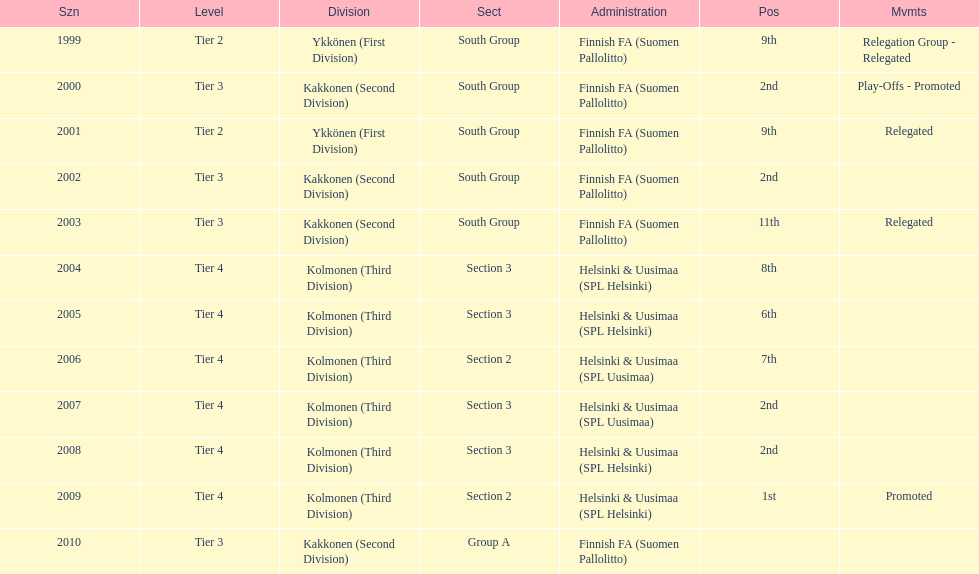How many times were they in tier 3? 4. Could you help me parse every detail presented in this table? {'header': ['Szn', 'Level', 'Division', 'Sect', 'Administration', 'Pos', 'Mvmts'], 'rows': [['1999', 'Tier 2', 'Ykkönen (First Division)', 'South Group', 'Finnish FA (Suomen Pallolitto)', '9th', 'Relegation Group - Relegated'], ['2000', 'Tier 3', 'Kakkonen (Second Division)', 'South Group', 'Finnish FA (Suomen Pallolitto)', '2nd', 'Play-Offs - Promoted'], ['2001', 'Tier 2', 'Ykkönen (First Division)', 'South Group', 'Finnish FA (Suomen Pallolitto)', '9th', 'Relegated'], ['2002', 'Tier 3', 'Kakkonen (Second Division)', 'South Group', 'Finnish FA (Suomen Pallolitto)', '2nd', ''], ['2003', 'Tier 3', 'Kakkonen (Second Division)', 'South Group', 'Finnish FA (Suomen Pallolitto)', '11th', 'Relegated'], ['2004', 'Tier 4', 'Kolmonen (Third Division)', 'Section 3', 'Helsinki & Uusimaa (SPL Helsinki)', '8th', ''], ['2005', 'Tier 4', 'Kolmonen (Third Division)', 'Section 3', 'Helsinki & Uusimaa (SPL Helsinki)', '6th', ''], ['2006', 'Tier 4', 'Kolmonen (Third Division)', 'Section 2', 'Helsinki & Uusimaa (SPL Uusimaa)', '7th', ''], ['2007', 'Tier 4', 'Kolmonen (Third Division)', 'Section 3', 'Helsinki & Uusimaa (SPL Uusimaa)', '2nd', ''], ['2008', 'Tier 4', 'Kolmonen (Third Division)', 'Section 3', 'Helsinki & Uusimaa (SPL Helsinki)', '2nd', ''], ['2009', 'Tier 4', 'Kolmonen (Third Division)', 'Section 2', 'Helsinki & Uusimaa (SPL Helsinki)', '1st', 'Promoted'], ['2010', 'Tier 3', 'Kakkonen (Second Division)', 'Group A', 'Finnish FA (Suomen Pallolitto)', '', '']]} 